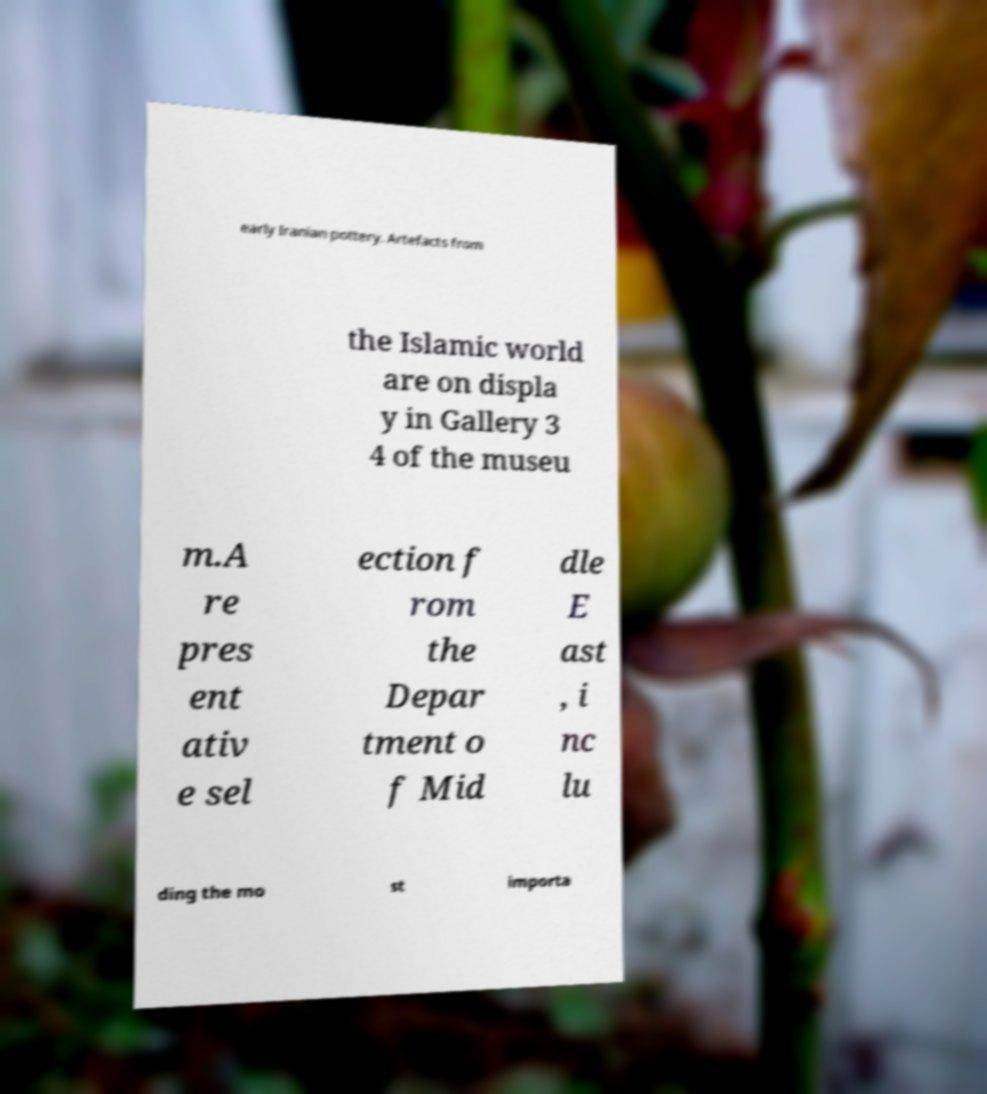I need the written content from this picture converted into text. Can you do that? early Iranian pottery. Artefacts from the Islamic world are on displa y in Gallery 3 4 of the museu m.A re pres ent ativ e sel ection f rom the Depar tment o f Mid dle E ast , i nc lu ding the mo st importa 